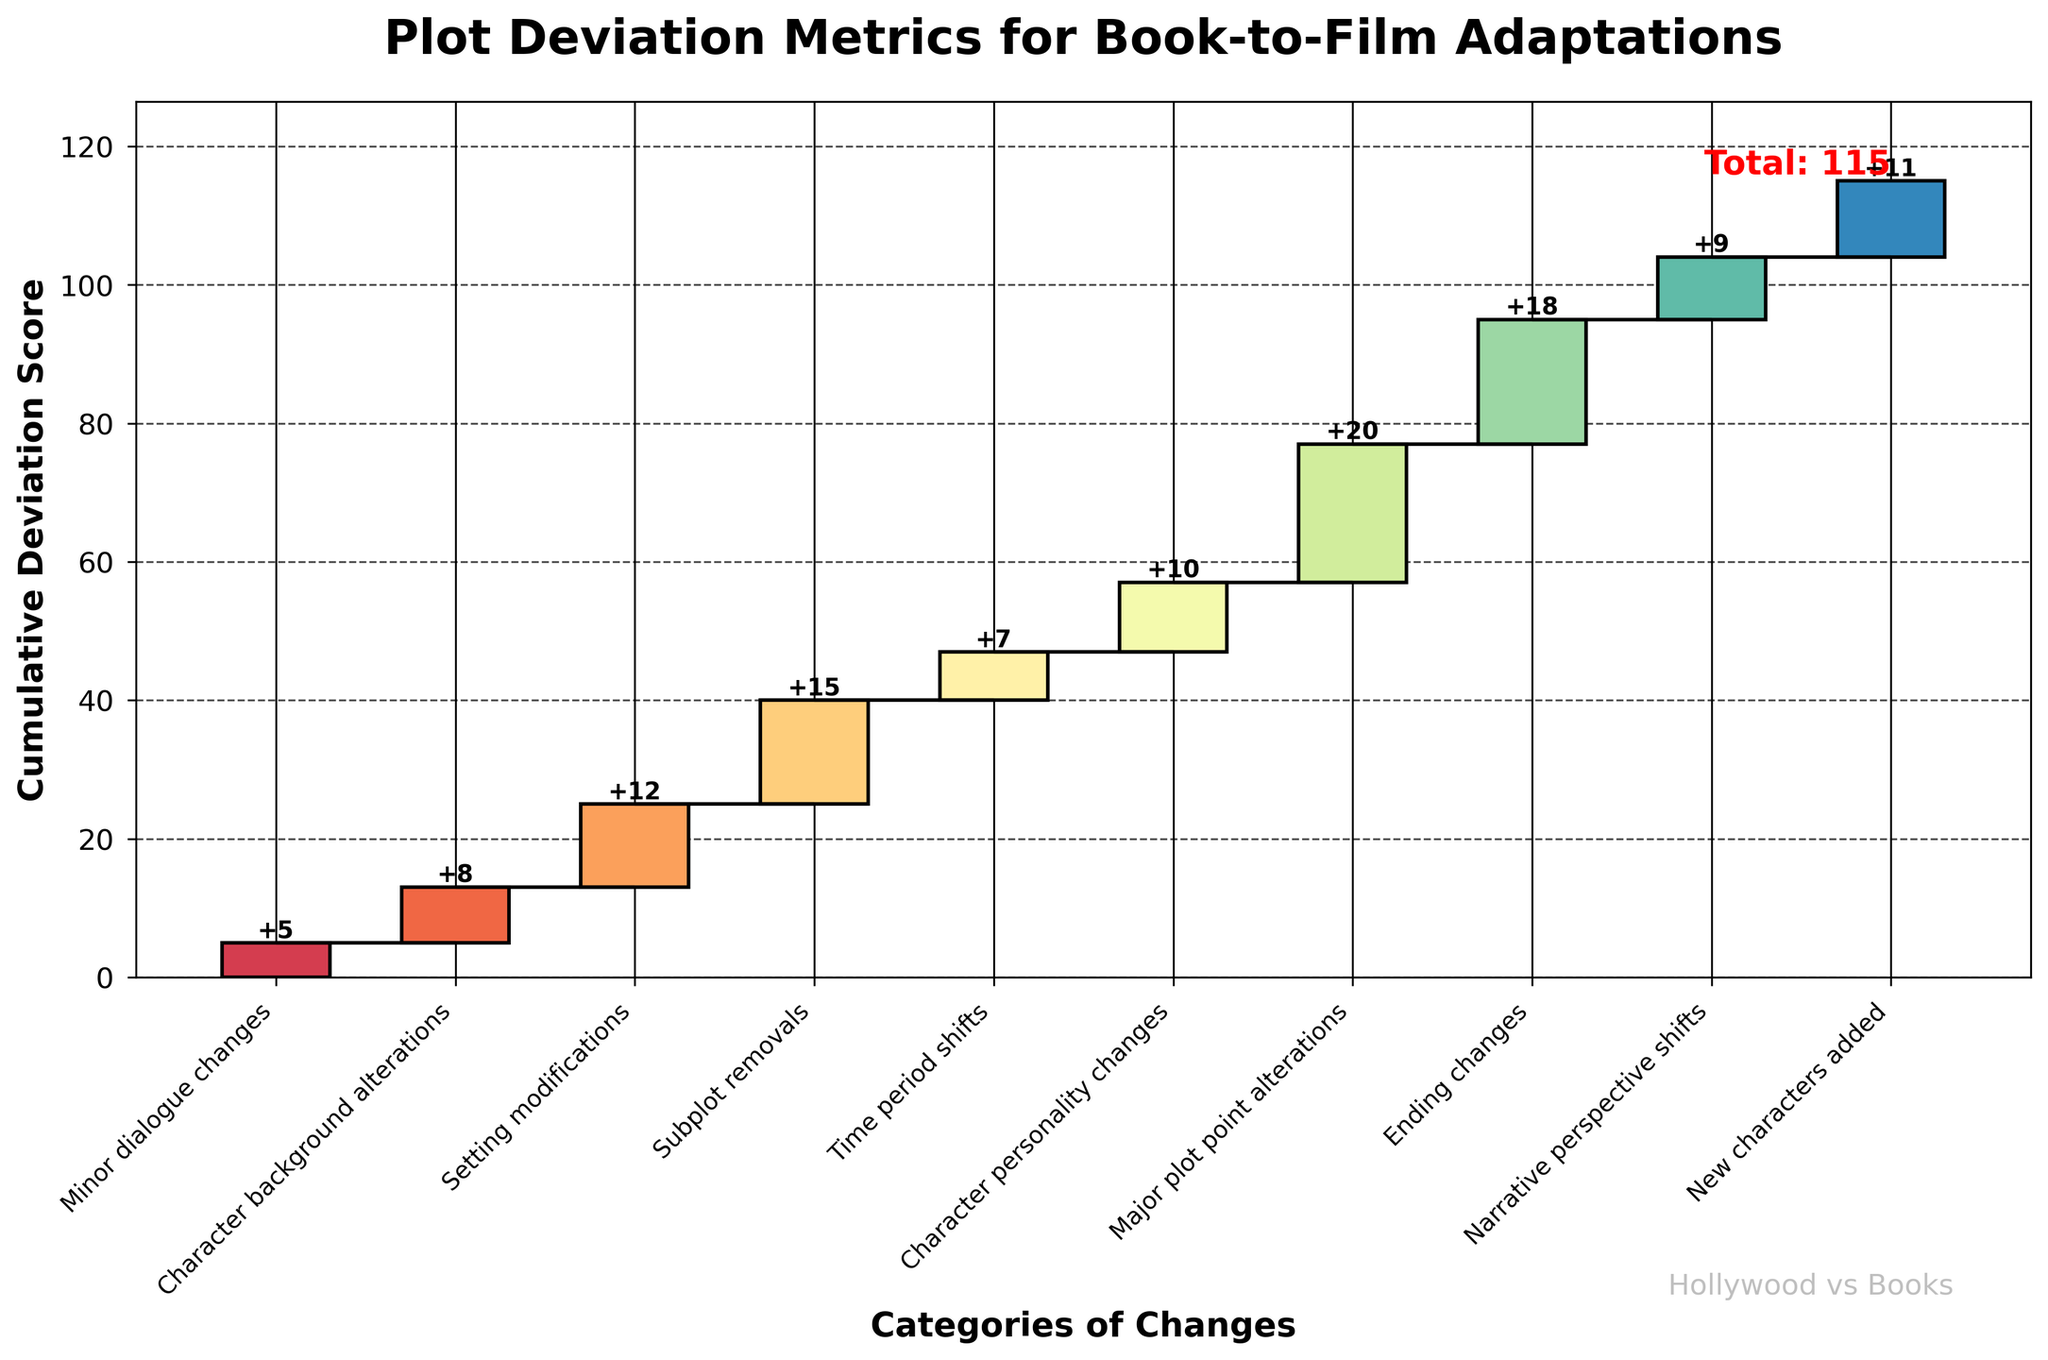What is the title of the chart? The title can be found at the top of the chart. The title is "Plot Deviation Metrics for Book-to-Film Adaptations."
Answer: Plot Deviation Metrics for Book-to-Film Adaptations What category shows the largest individual plot deviation? By looking at the heights of the bars, the tallest one represents "Major plot point alterations" with a value of 20.
Answer: Major plot point alterations Which category follows "Minor dialogue changes" in the plot deviation sequence? The next category after "Minor dialogue changes" is "Character background alterations," as the categories are listed in sequence along the x-axis.
Answer: Character background alterations What are the cumulative deviations up to "Character background alterations"? The cumulative deviation up to "Character background alterations" would be the sum of "Minor dialogue changes" and "Character background alterations," which are 5 and 8, respectively. So, 5 + 8 = 13.
Answer: 13 How does the deviation score for "Setting modifications" compare to that for "Character personality changes"? The deviation score for "Setting modifications" is 12, while for "Character personality changes," it is 10. Since 12 > 10, "Setting modifications" has a higher deviation score.
Answer: Setting modifications is higher What is the total cumulative deviation score in the chart? The total cumulative deviation score can be found at the end of the chart, which is annotated as "Total: 115."
Answer: 115 What are the categories with a deviation score greater than 10? From the figure, the categories with deviation scores greater than 10 are "Setting modifications" (12), "Subplot removals" (15), "Major plot point alterations" (20), "Ending changes" (18), and "New characters added" (11).
Answer: Setting modifications, Subplot removals, Major plot point alterations, Ending changes, New characters added Which categories contribute to narrative structure changes the most? Categories that contribute to narrative structure changes include "Subplot removals" (15), "Major plot point alterations" (20), "Ending changes" (18), and "Narrative perspective shifts" (9). To identify the highest contributor, compare their values. "Major plot point alterations" is the highest with 20.
Answer: Major plot point alterations What are the differences in deviation scores between "Time period shifts" and "Character background alterations"? The deviation score for "Time period shifts" is 7, and for "Character background alterations," it is 8. The difference between them is 8 - 7 = 1.
Answer: 1 What is the average deviation score for the categories listed? To find the average, sum all the individual deviation scores and then divide by the number of categories: (5 + 8 + 12 + 15 + 7 + 10 + 20 + 18 + 9 + 11) / 10. This sums to 115, so the average is 115 / 10 = 11.5.
Answer: 11.5 